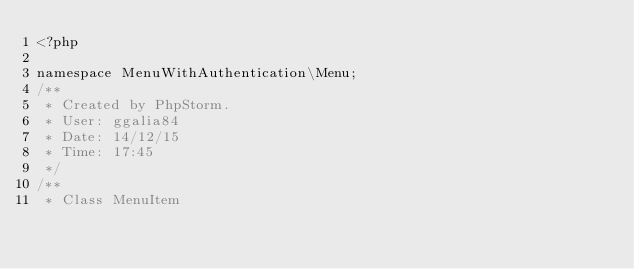Convert code to text. <code><loc_0><loc_0><loc_500><loc_500><_PHP_><?php

namespace MenuWithAuthentication\Menu;
/**
 * Created by PhpStorm.
 * User: ggalia84
 * Date: 14/12/15
 * Time: 17:45
 */
/**
 * Class MenuItem</code> 